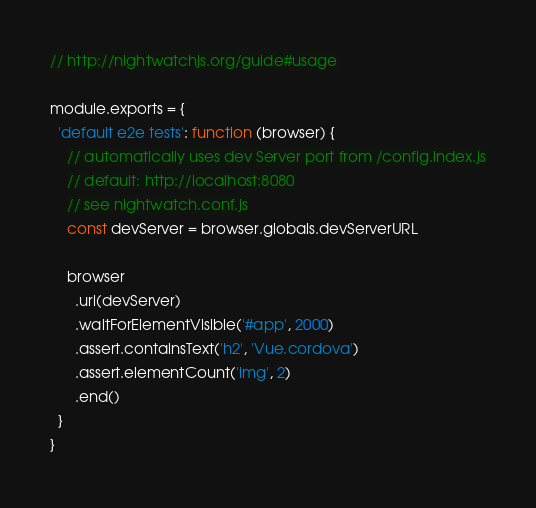Convert code to text. <code><loc_0><loc_0><loc_500><loc_500><_JavaScript_>// http://nightwatchjs.org/guide#usage

module.exports = {
  'default e2e tests': function (browser) {
    // automatically uses dev Server port from /config.index.js
    // default: http://localhost:8080
    // see nightwatch.conf.js
    const devServer = browser.globals.devServerURL

    browser
      .url(devServer)
      .waitForElementVisible('#app', 2000)
      .assert.containsText('h2', 'Vue.cordova')
      .assert.elementCount('img', 2)
      .end()
  }
}
</code> 